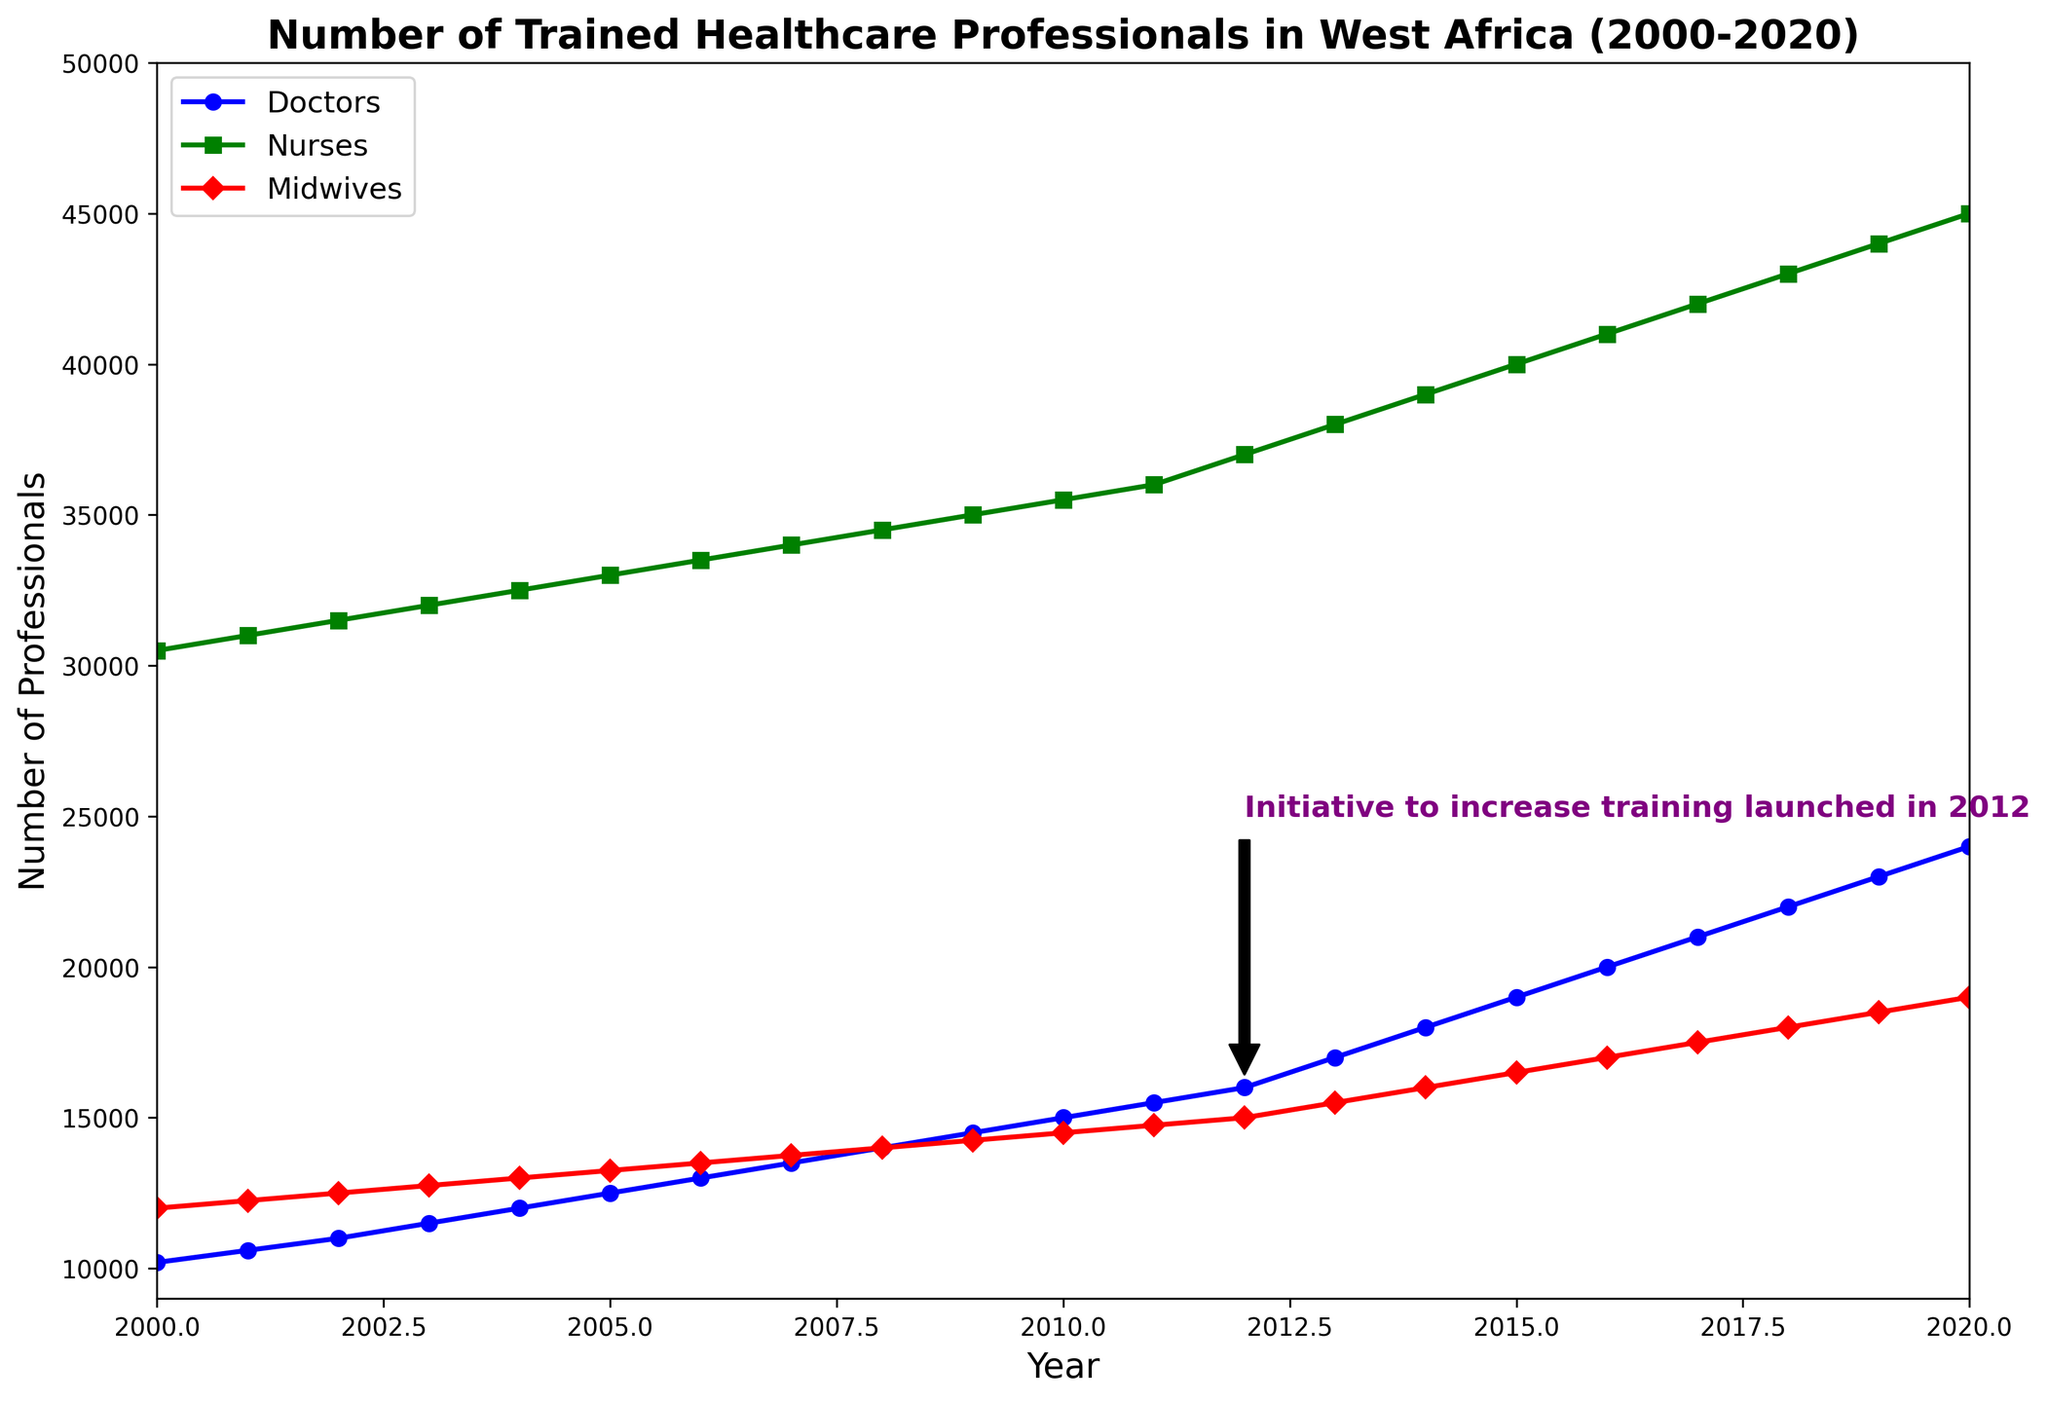How many more nurses were there in 2020 compared to 2012? In 2012, the number of nurses was 37,000, and in 2020, it was 45,000. The difference can be calculated as 45,000 - 37,000.
Answer: 8,000 When was the training initiative launched, and what is its annotation on the plot? The annotation on the plot indicates the initiative was launched in 2012, and the annotation reads "Initiative to increase training launched in 2012".
Answer: 2012, "Initiative to increase training launched in 2012" Comparing doctors and midwives, which group had a higher increase from 2000 to 2020? The number of doctors increased from 10,200 in 2000 to 24,000 in 2020, a difference of 13,800. The number of midwives increased from 12,000 in 2000 to 19,000 in 2020, a difference of 7,000. Therefore, doctors had a higher increase.
Answer: Doctors What was the approximate number of midwives in 2008, and how does this relate visually in the plot? The number of midwives in 2008 was 14,000. The red line representing midwives can be seen visually at this height on the plot for the year 2008.
Answer: 14,000 What pattern or trend can be observed from 2012 onwards in the number of trained healthcare professionals? After 2012, all three categories (Doctors, Nurses, and Midwives) show a steeper upward trend compared to previous years. This increased training corresponds to the initiative launched in 2012.
Answer: Upward trend How many years did it take for the number of doctors to double from what it was in 2000? In 2000, the number of doctors was 10,200. Doubling this number gives us 20,400. By looking at the plot, this number was reached around the year 2017. Therefore, it took 17 years (2017 - 2000).
Answer: 17 years Which healthcare professional group had the highest number in 2016, and what was that number? In 2016, the green line for Nurses reaches the highest point among the three groups at 41,000.
Answer: Nurses, 41,000 What significant change occurred in the trend of nurses from 2011 to 2012? The plot shows a noticeable increase in the slope of the green line (Nurses) between 2011 and 2012, suggesting a significant increase in the number of trainees due to the initiative launched in 2012.
Answer: Increased slope/steep rise What was the average number of doctors in the years from 2010 to 2014? The numbers for doctors from 2010 to 2014 were: 15,000, 15,500, 16,000, 17,000, and 18,000. The sum is 15,000 + 15,500 + 16,000 + 17,000 + 18,000 = 81,500. Dividing by 5, the average is 81,500 / 5.
Answer: 16,300 By how much did the number of midwives increase between 2015 and 2020? In 2015, the number of midwives was 16,500, and in 2020 it was 19,000. The increase is 19,000 - 16,500.
Answer: 2,500 